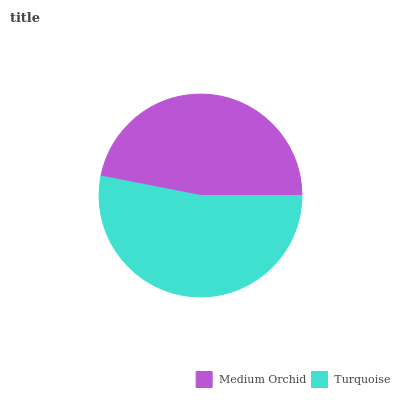Is Medium Orchid the minimum?
Answer yes or no. Yes. Is Turquoise the maximum?
Answer yes or no. Yes. Is Turquoise the minimum?
Answer yes or no. No. Is Turquoise greater than Medium Orchid?
Answer yes or no. Yes. Is Medium Orchid less than Turquoise?
Answer yes or no. Yes. Is Medium Orchid greater than Turquoise?
Answer yes or no. No. Is Turquoise less than Medium Orchid?
Answer yes or no. No. Is Turquoise the high median?
Answer yes or no. Yes. Is Medium Orchid the low median?
Answer yes or no. Yes. Is Medium Orchid the high median?
Answer yes or no. No. Is Turquoise the low median?
Answer yes or no. No. 